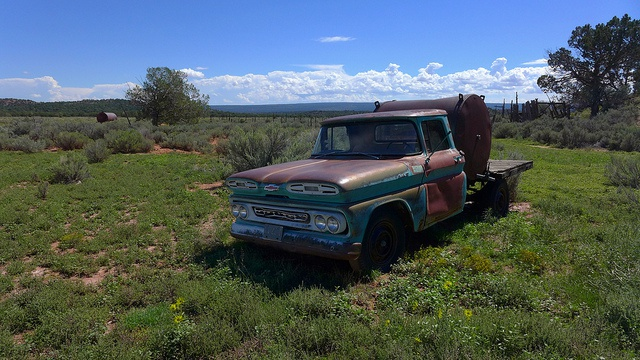Describe the objects in this image and their specific colors. I can see a truck in gray, black, darkblue, and blue tones in this image. 